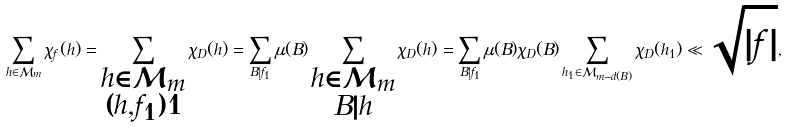<formula> <loc_0><loc_0><loc_500><loc_500>\sum _ { h \in \mathcal { M } _ { m } } \chi _ { f } ( h ) = \sum _ { \substack { h \in \mathcal { M } _ { m } \\ ( h , f _ { 1 } ) = 1 } } \chi _ { D } ( h ) = \sum _ { B | f _ { 1 } } \mu ( B ) \sum _ { \substack { h \in \mathcal { M } _ { m } \\ B | h } } \chi _ { D } ( h ) = \sum _ { B | f _ { 1 } } \mu ( B ) \chi _ { D } ( B ) \sum _ { h _ { 1 } \in \mathcal { M } _ { m - d ( B ) } } \chi _ { D } ( h _ { 1 } ) \ll \sqrt { | f | } ,</formula> 